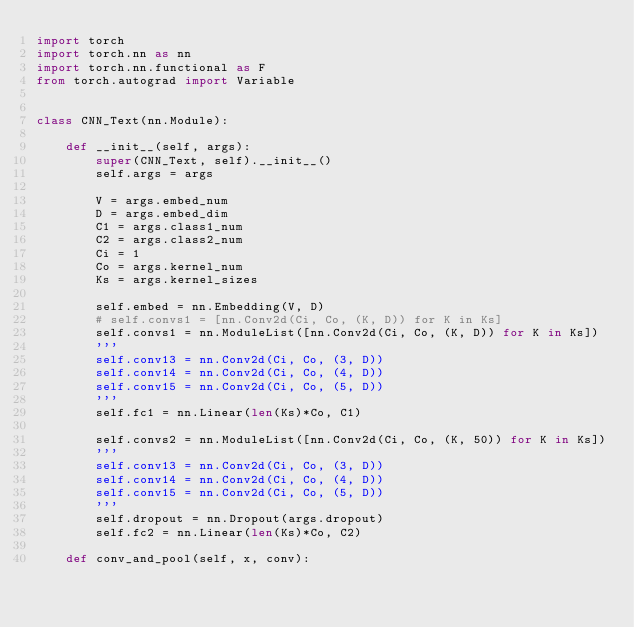<code> <loc_0><loc_0><loc_500><loc_500><_Python_>import torch
import torch.nn as nn
import torch.nn.functional as F
from torch.autograd import Variable


class CNN_Text(nn.Module):
    
    def __init__(self, args):
        super(CNN_Text, self).__init__()
        self.args = args
        
        V = args.embed_num
        D = args.embed_dim
        C1 = args.class1_num
        C2 = args.class2_num
        Ci = 1
        Co = args.kernel_num
        Ks = args.kernel_sizes

        self.embed = nn.Embedding(V, D)
        # self.convs1 = [nn.Conv2d(Ci, Co, (K, D)) for K in Ks]
        self.convs1 = nn.ModuleList([nn.Conv2d(Ci, Co, (K, D)) for K in Ks])
        '''
        self.conv13 = nn.Conv2d(Ci, Co, (3, D))
        self.conv14 = nn.Conv2d(Ci, Co, (4, D))
        self.conv15 = nn.Conv2d(Ci, Co, (5, D))
        '''
        self.fc1 = nn.Linear(len(Ks)*Co, C1)

        self.convs2 = nn.ModuleList([nn.Conv2d(Ci, Co, (K, 50)) for K in Ks])
        '''
        self.conv13 = nn.Conv2d(Ci, Co, (3, D))
        self.conv14 = nn.Conv2d(Ci, Co, (4, D))
        self.conv15 = nn.Conv2d(Ci, Co, (5, D))
        '''
        self.dropout = nn.Dropout(args.dropout)
        self.fc2 = nn.Linear(len(Ks)*Co, C2)

    def conv_and_pool(self, x, conv):</code> 